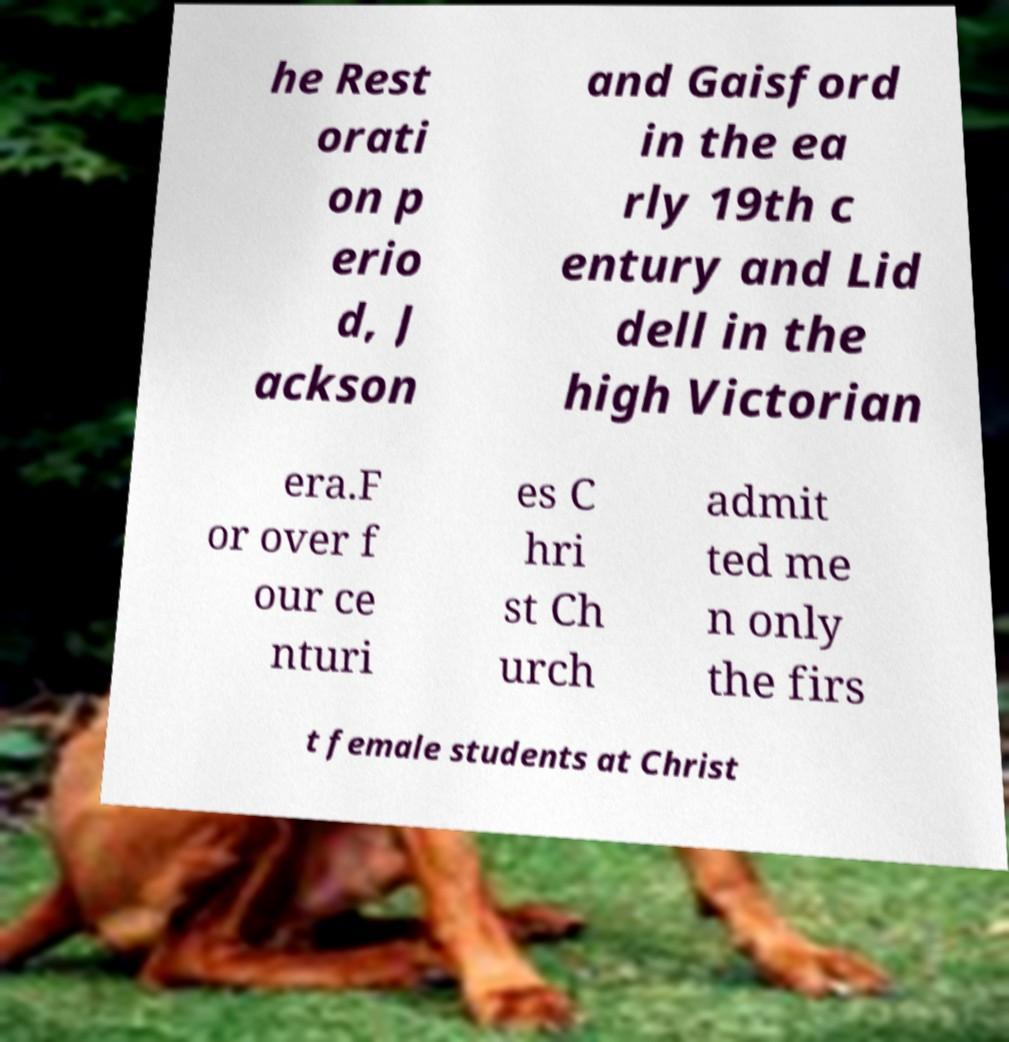Can you read and provide the text displayed in the image?This photo seems to have some interesting text. Can you extract and type it out for me? he Rest orati on p erio d, J ackson and Gaisford in the ea rly 19th c entury and Lid dell in the high Victorian era.F or over f our ce nturi es C hri st Ch urch admit ted me n only the firs t female students at Christ 